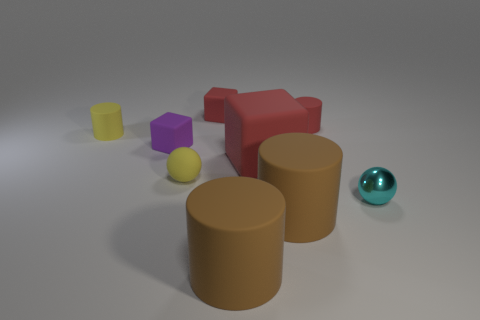What number of other big matte cubes are the same color as the large cube?
Offer a terse response. 0. There is another red block that is the same material as the tiny red block; what is its size?
Offer a terse response. Large. What number of things are either red cubes or tiny yellow rubber objects?
Give a very brief answer. 4. The large block to the right of the tiny purple rubber object is what color?
Your answer should be compact. Red. The yellow matte thing that is the same shape as the small cyan thing is what size?
Provide a short and direct response. Small. How many things are either tiny spheres to the right of the tiny red block or matte cylinders right of the large red matte thing?
Offer a terse response. 3. There is a cylinder that is both on the right side of the large red block and in front of the large red cube; how big is it?
Ensure brevity in your answer.  Large. There is a small purple object; is it the same shape as the red thing that is in front of the tiny yellow cylinder?
Make the answer very short. Yes. What number of things are either matte cubes in front of the red rubber cylinder or purple things?
Offer a very short reply. 2. Is the purple cube made of the same material as the tiny cube to the right of the purple rubber block?
Provide a short and direct response. Yes. 